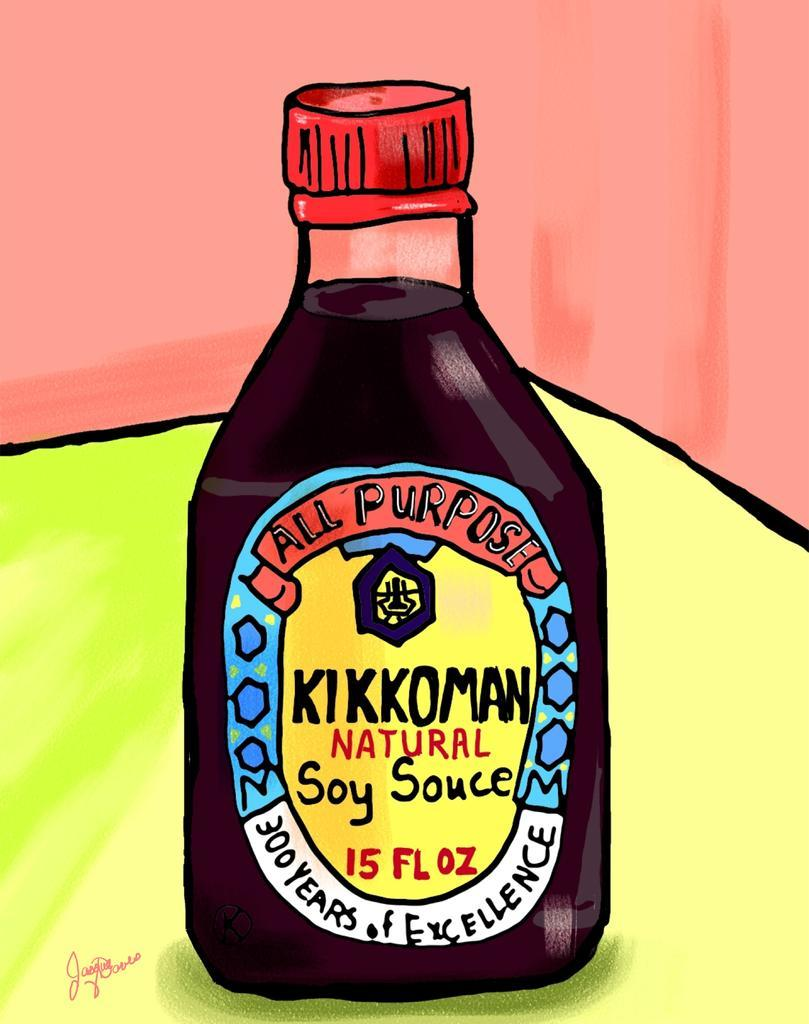<image>
Summarize the visual content of the image. A cartoon drawing of kikkoman soy sauce on yellow table against a red wall.. 